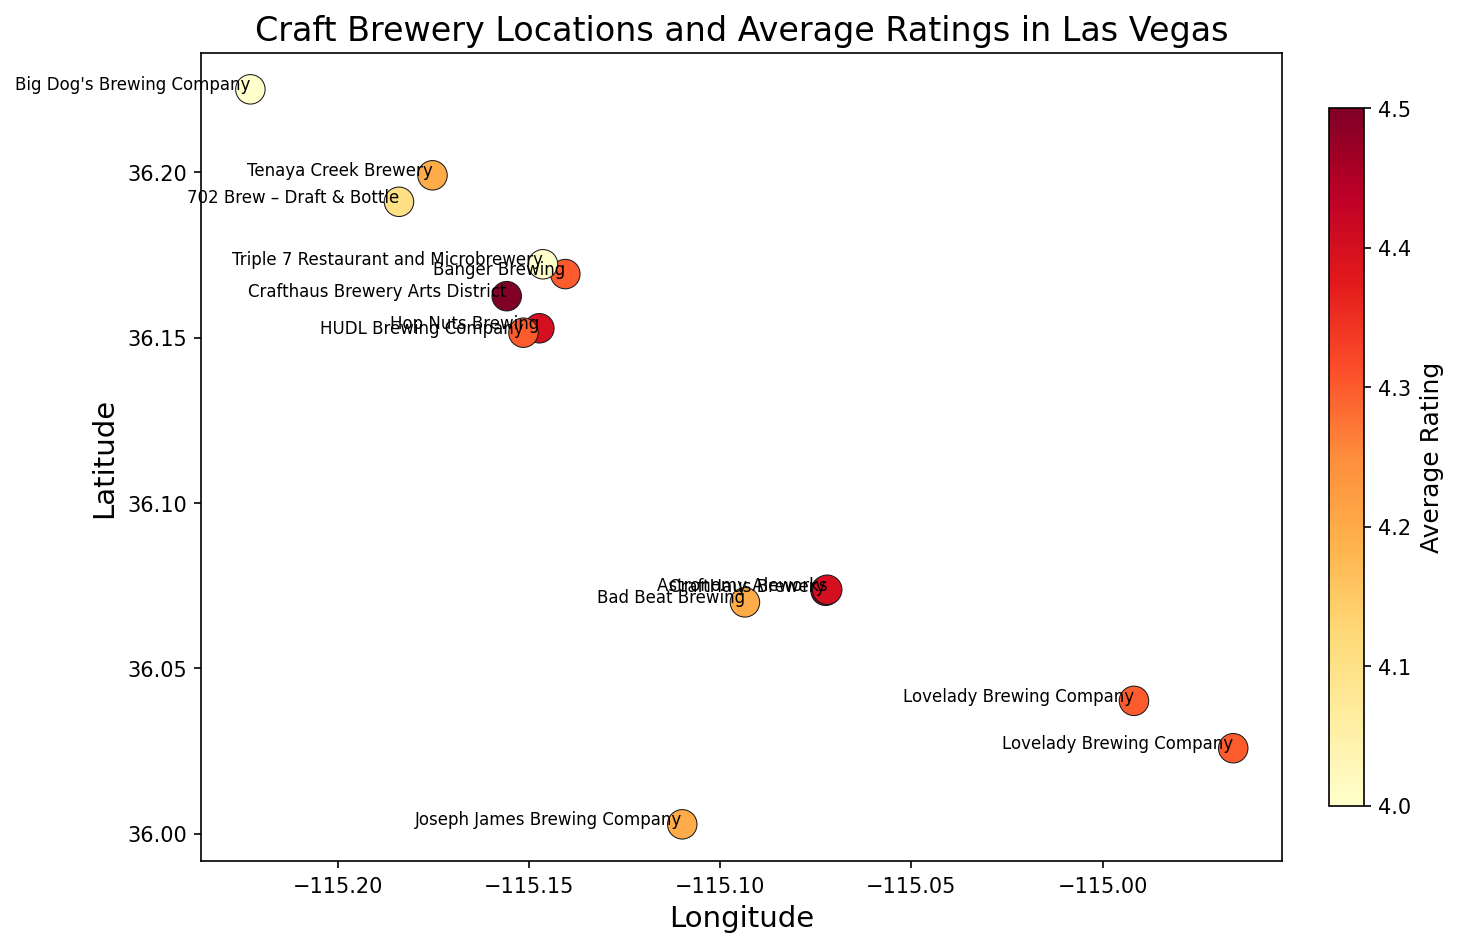What's the highest-rated brewery on the map? To determine the highest-rated brewery, observe the brewery with the most red/orange-colored marker, which is indicative of the highest rating on the color scale. Check corresponding annotations for the exact brewery name.
Answer: CraftHaus Brewery (both locations), 4.5 Which brewery has the southernmost location? Identify the brewery marker located at the lowest (southernmost) latitude position on the map. Check the annotation closest to this position for the brewery name.
Answer: Joseph James Brewing Company How many breweries have an average rating of 4.3? Look for markers with a color that matches the part of the color bar indicating a rating of 4.3. Count these markers and list the corresponding brewery names from the annotations.
Answer: 4 (Banger Brewing, Lovelady Brewing Company, HUDL Brewing Company, Lovelady Brewing Company (second location)) Which brewery is closest to 36.172169 latitude and -115.146369 longitude? Locate the coordinates 36.172169 latitude, -115.146369 longitude on the map. Identify the nearest marker and read its annotation.
Answer: Triple 7 Restaurant and Microbrewery What is the approximate average rating of all breweries combined? Sum all the average ratings from the annotations, then divide by the total number of breweries: (4.2 + 4.3 + 4.4 + 4.5 + 4.3 + 4.2 + 4.4 + 4.1 + 4.0 + 4.0 + 4.3 + 4.5 + 4.2 + 4.3) / 14 ≈ 4.29
Answer: 4.29 Which brewery has the highest rating among those west of -115.15 longitude? Filter the markers by those positioned to the left (west) of -115.15 longitude. Identify the marker with the highest rating color and check its annotation.
Answer: Big Dog's Brewing Company and 702 Brew – Draft & Bottle, both rated 4.1 Which brewery has the second lowest rating? Identify and order the rating colors from highest to lowest. The second lowest color after identifying the lowest corresponds to the brewery annotation.
Answer: Triple 7 Restaurant and Microbrewery, Big Dog's Brewing Company Is the average rating of breweries north of 36.15 latitude higher than those south of it? Calculate the average for breweries north of 36.15, then for those south of 36.15: North: (4.2 + 4.1 + 4.0 + 4.0) / 4 = 4.075, South: (4.5 + 4.3 + 4.3 + 4.4 + 4.3 + 4.5 + 4.2 + 4.4 + 4.3 + 4.2) / 10 = 4.34. Compare the two averages.
Answer: South (4.34) is higher than North (4.075) 